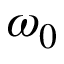<formula> <loc_0><loc_0><loc_500><loc_500>\omega _ { 0 }</formula> 